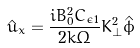<formula> <loc_0><loc_0><loc_500><loc_500>\hat { \bar { u } } _ { x } = \frac { i B _ { 0 } ^ { 2 } C _ { \epsilon 1 } } { 2 k \Omega } K _ { \perp } ^ { 2 } \hat { \phi }</formula> 